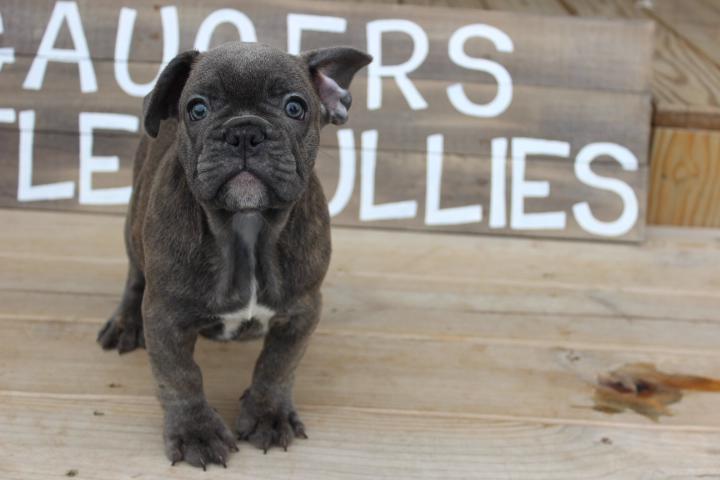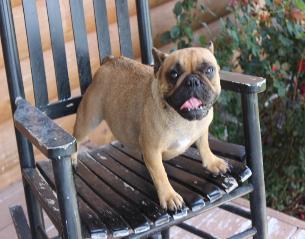The first image is the image on the left, the second image is the image on the right. For the images displayed, is the sentence "Two puppies are inside a shopping cart." factually correct? Answer yes or no. No. The first image is the image on the left, the second image is the image on the right. Analyze the images presented: Is the assertion "A dark dog is wearing a blue vest and is inside of a shopping cart." valid? Answer yes or no. No. 